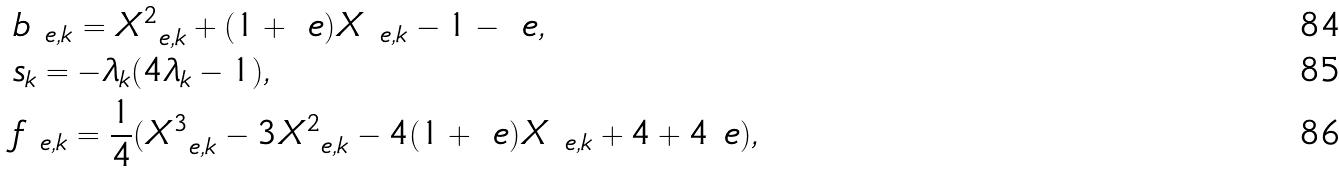<formula> <loc_0><loc_0><loc_500><loc_500>& b _ { \ e , k } = X ^ { 2 } _ { \ e , k } + ( 1 + \ e ) X _ { \ e , k } - 1 - \ e , \\ & s _ { k } = - \lambda _ { k } ( 4 \lambda _ { k } - 1 ) , \\ & f _ { \ e , k } = \frac { 1 } { 4 } ( X ^ { 3 } _ { \ e , k } - 3 X _ { \ e , k } ^ { 2 } - 4 ( 1 + \ e ) X _ { \ e , k } + 4 + 4 \ e ) ,</formula> 